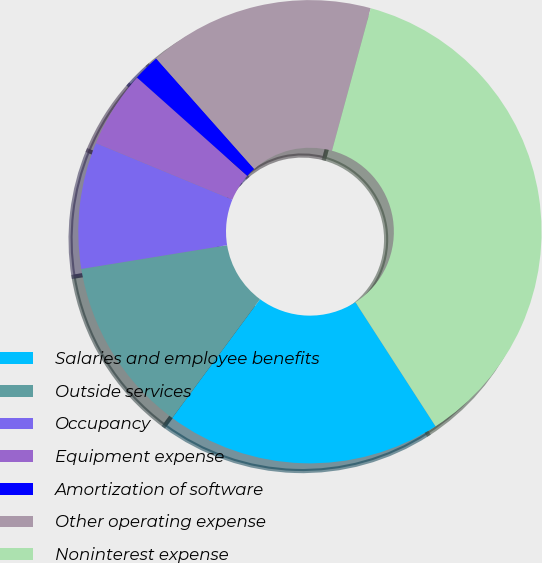<chart> <loc_0><loc_0><loc_500><loc_500><pie_chart><fcel>Salaries and employee benefits<fcel>Outside services<fcel>Occupancy<fcel>Equipment expense<fcel>Amortization of software<fcel>Other operating expense<fcel>Noninterest expense<nl><fcel>19.26%<fcel>12.3%<fcel>8.82%<fcel>5.34%<fcel>1.86%<fcel>15.78%<fcel>36.65%<nl></chart> 